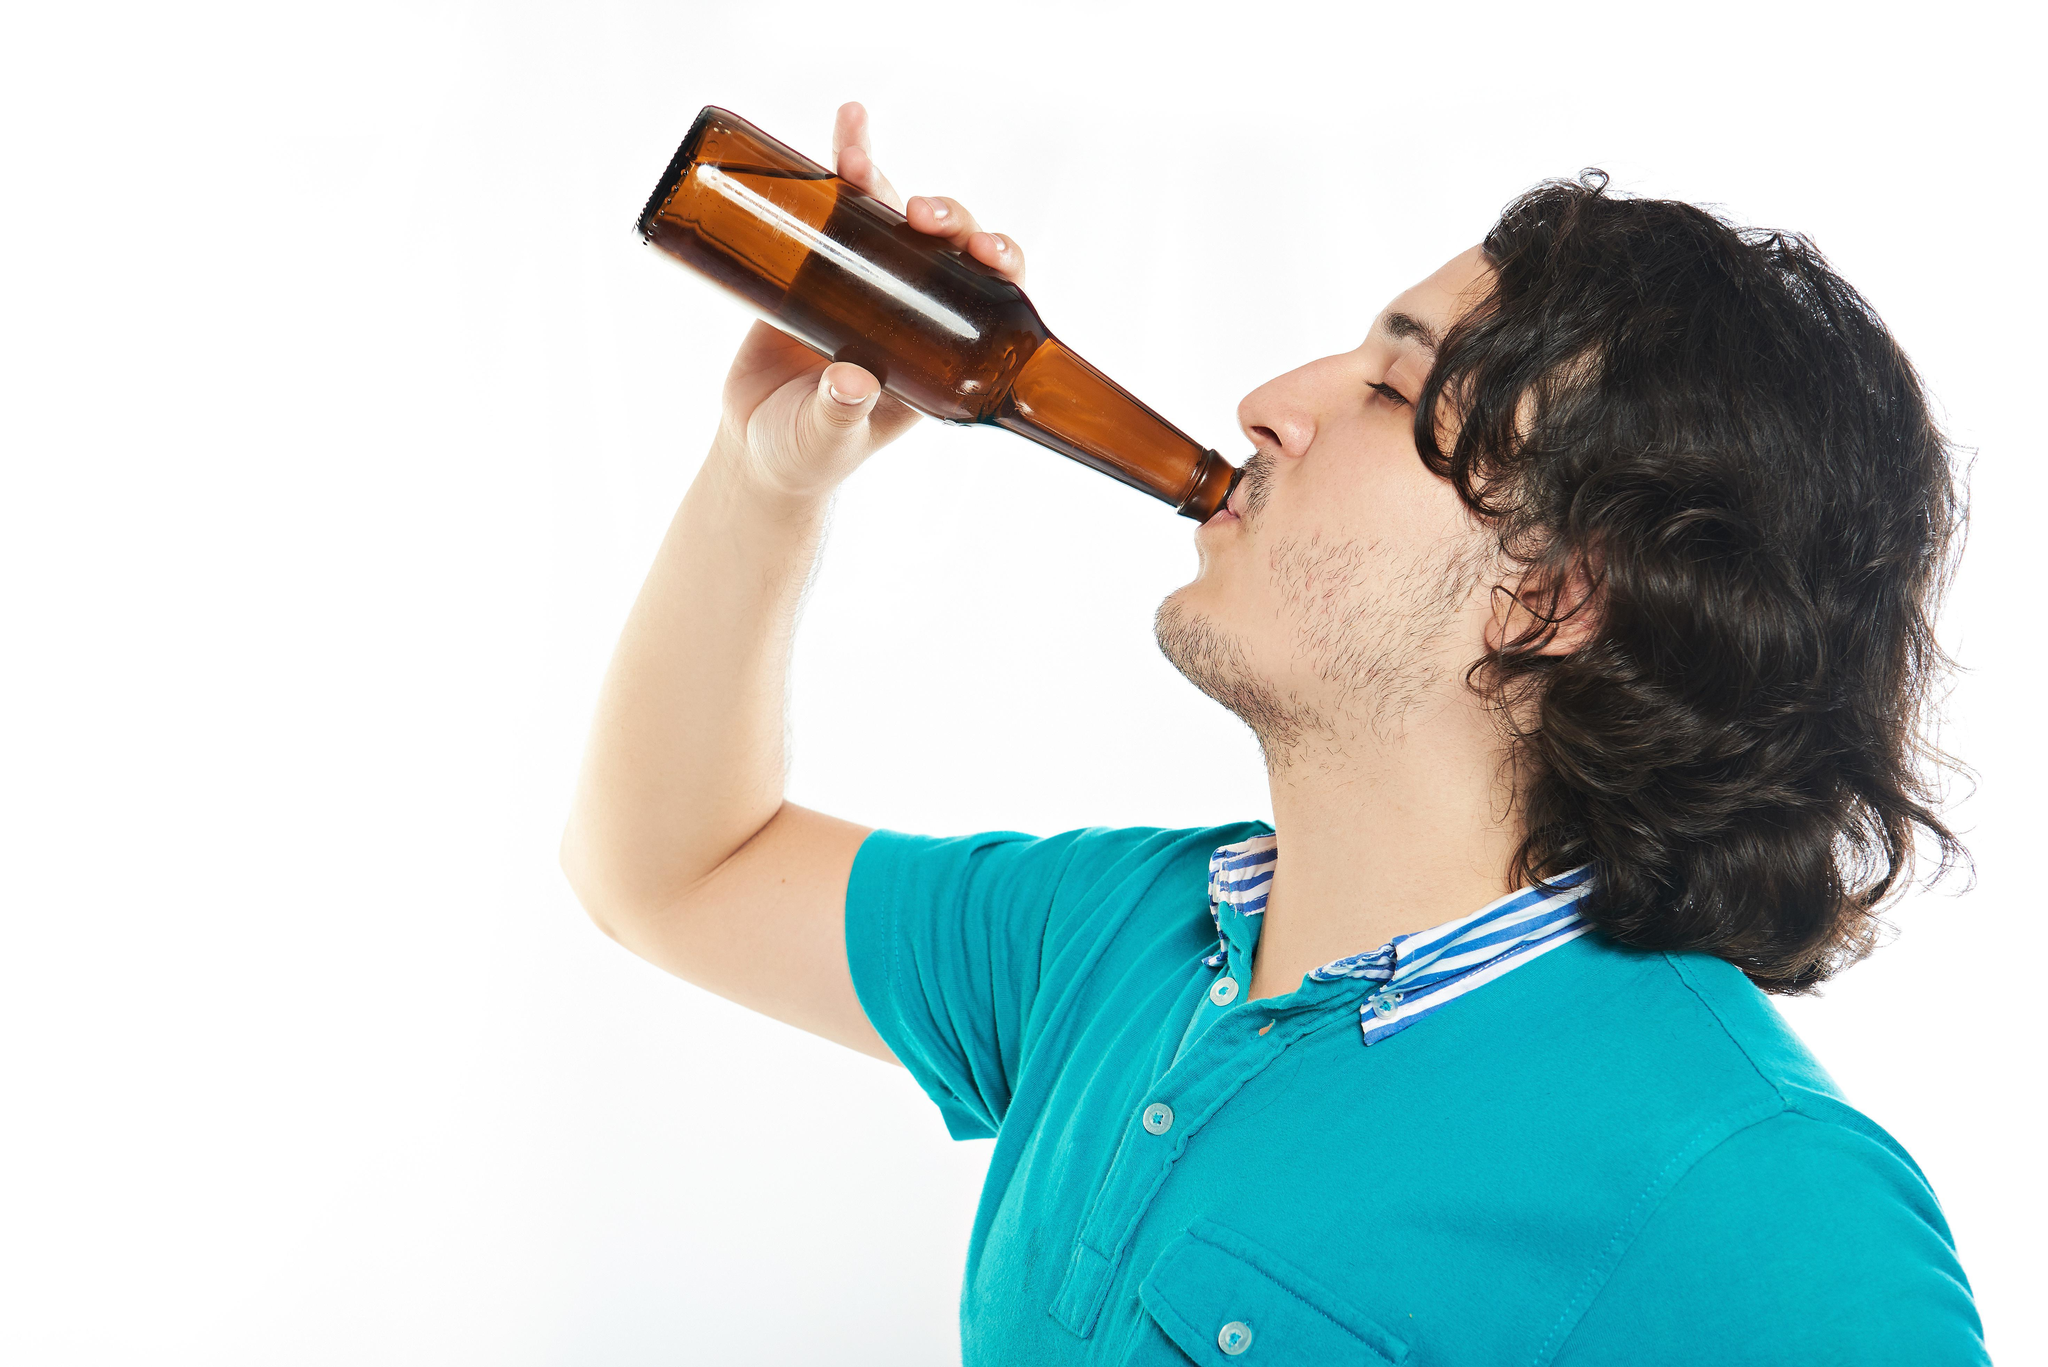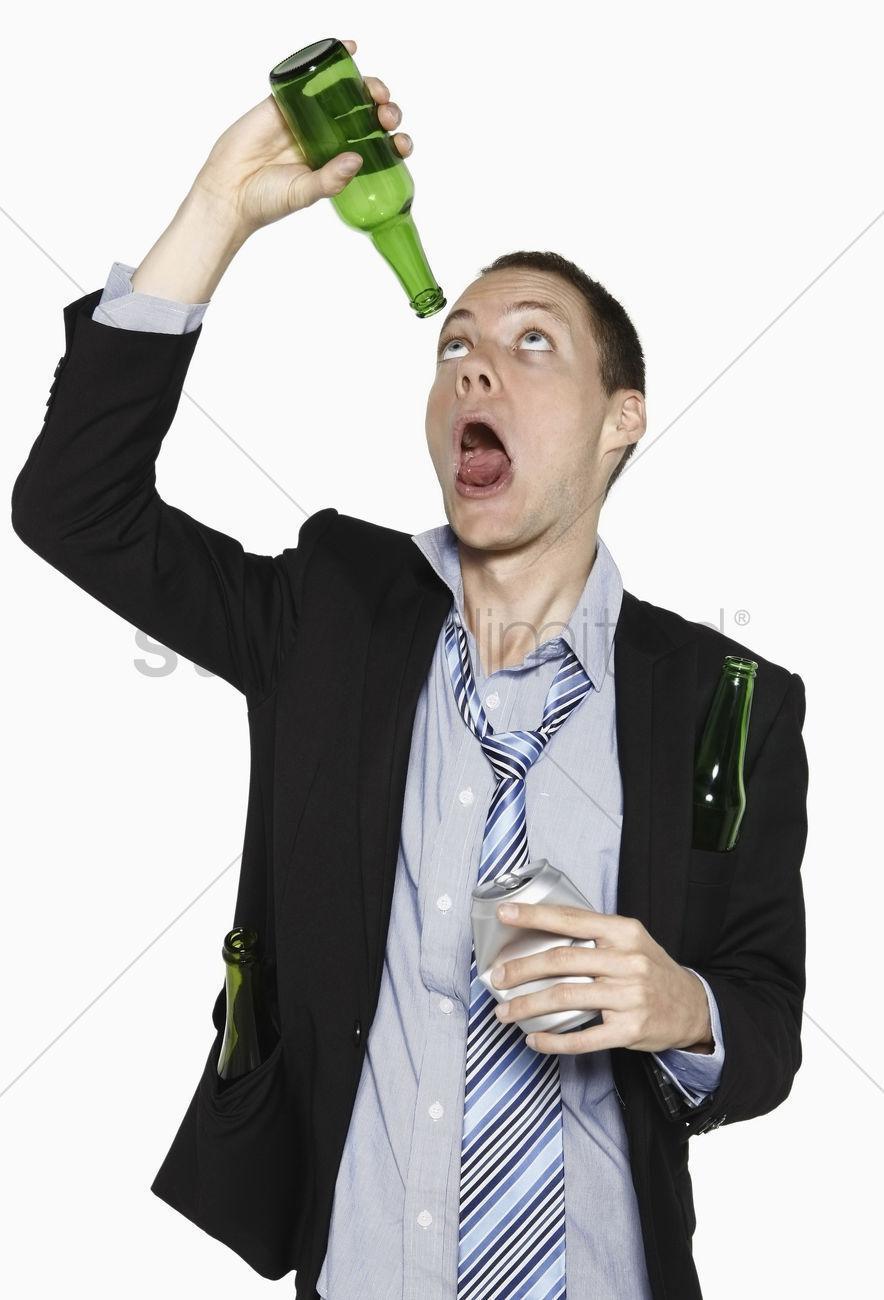The first image is the image on the left, the second image is the image on the right. Evaluate the accuracy of this statement regarding the images: "The man in the image on the left is holding a green bottle.". Is it true? Answer yes or no. No. 